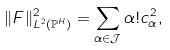Convert formula to latex. <formula><loc_0><loc_0><loc_500><loc_500>\| F \| _ { L ^ { 2 } ( \mathbb { P } ^ { H } ) } ^ { 2 } = \sum _ { \alpha \in \mathcal { J } } \alpha ! c _ { \alpha } ^ { 2 } ,</formula> 